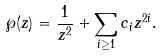Convert formula to latex. <formula><loc_0><loc_0><loc_500><loc_500>\wp ( z ) = \frac { 1 } { z ^ { 2 } } + \sum _ { i \geq 1 } c _ { i } z ^ { 2 i } .</formula> 